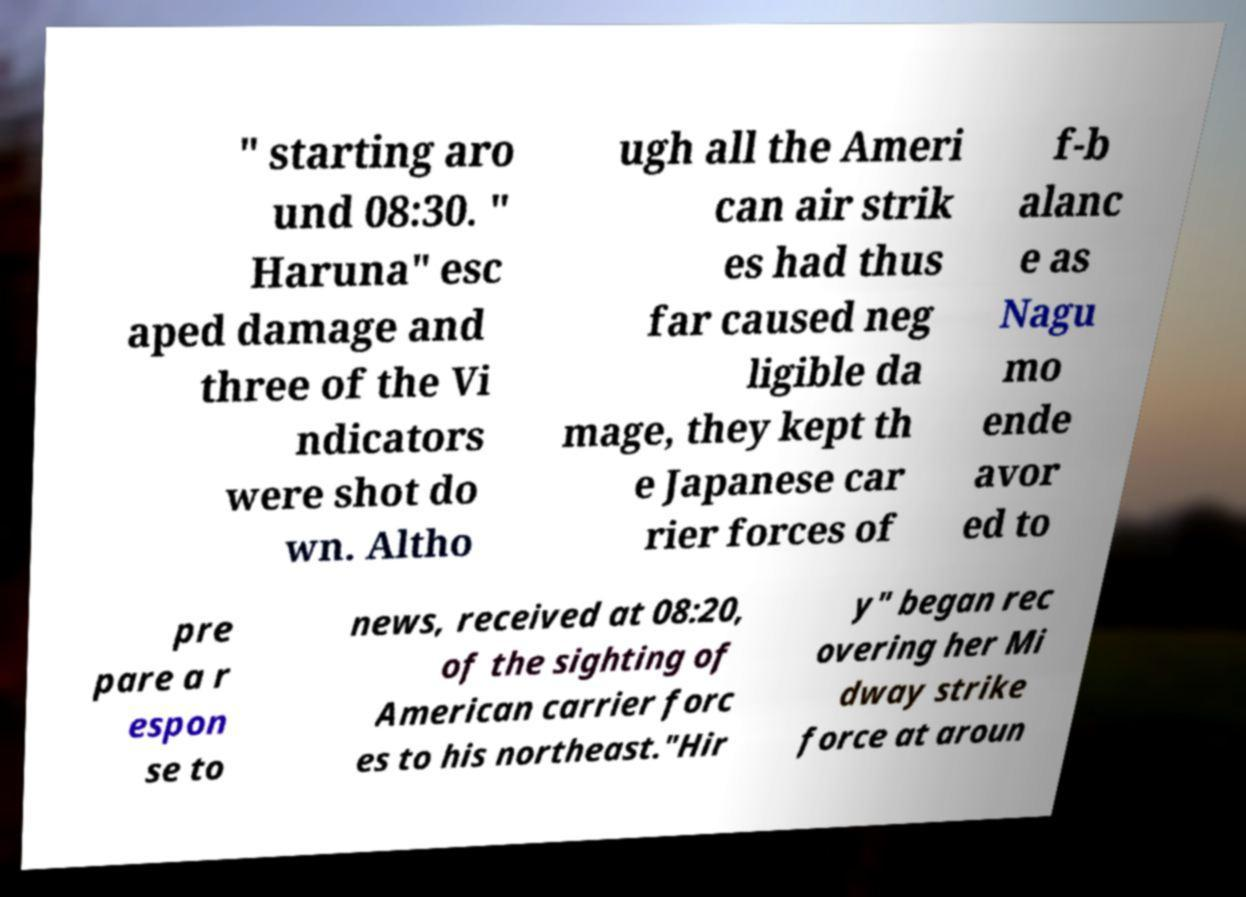Can you accurately transcribe the text from the provided image for me? " starting aro und 08:30. " Haruna" esc aped damage and three of the Vi ndicators were shot do wn. Altho ugh all the Ameri can air strik es had thus far caused neg ligible da mage, they kept th e Japanese car rier forces of f-b alanc e as Nagu mo ende avor ed to pre pare a r espon se to news, received at 08:20, of the sighting of American carrier forc es to his northeast."Hir y" began rec overing her Mi dway strike force at aroun 